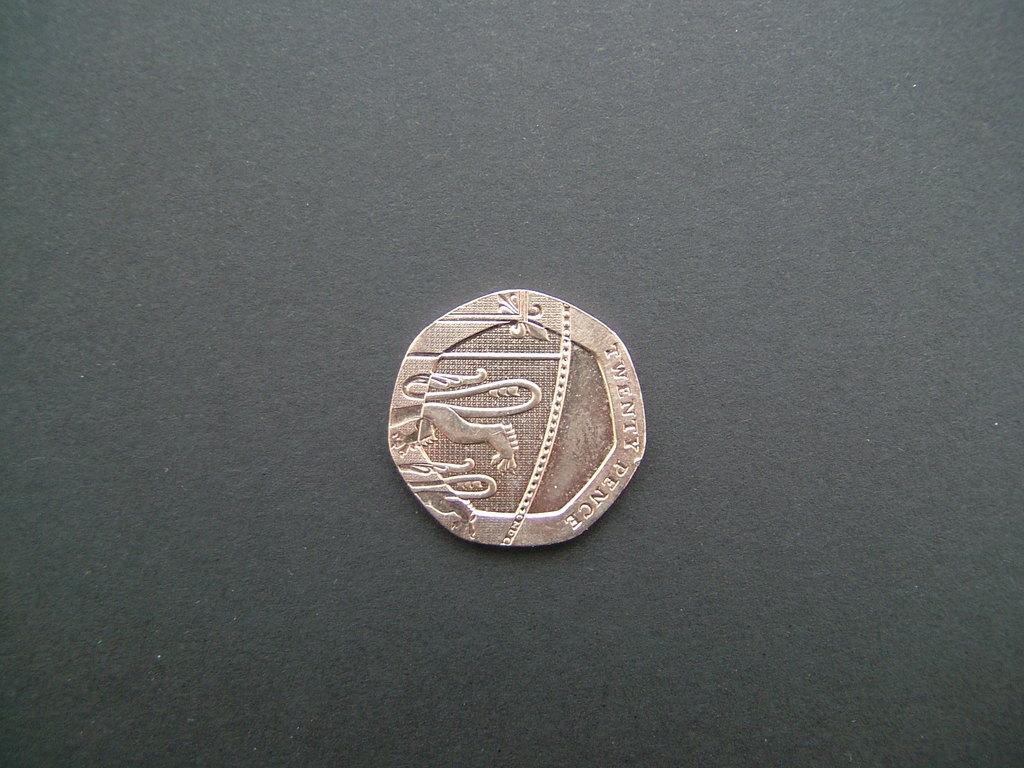This is twenty what?
Ensure brevity in your answer.  Pence. How many pences is this?
Your answer should be compact. Twenty. 